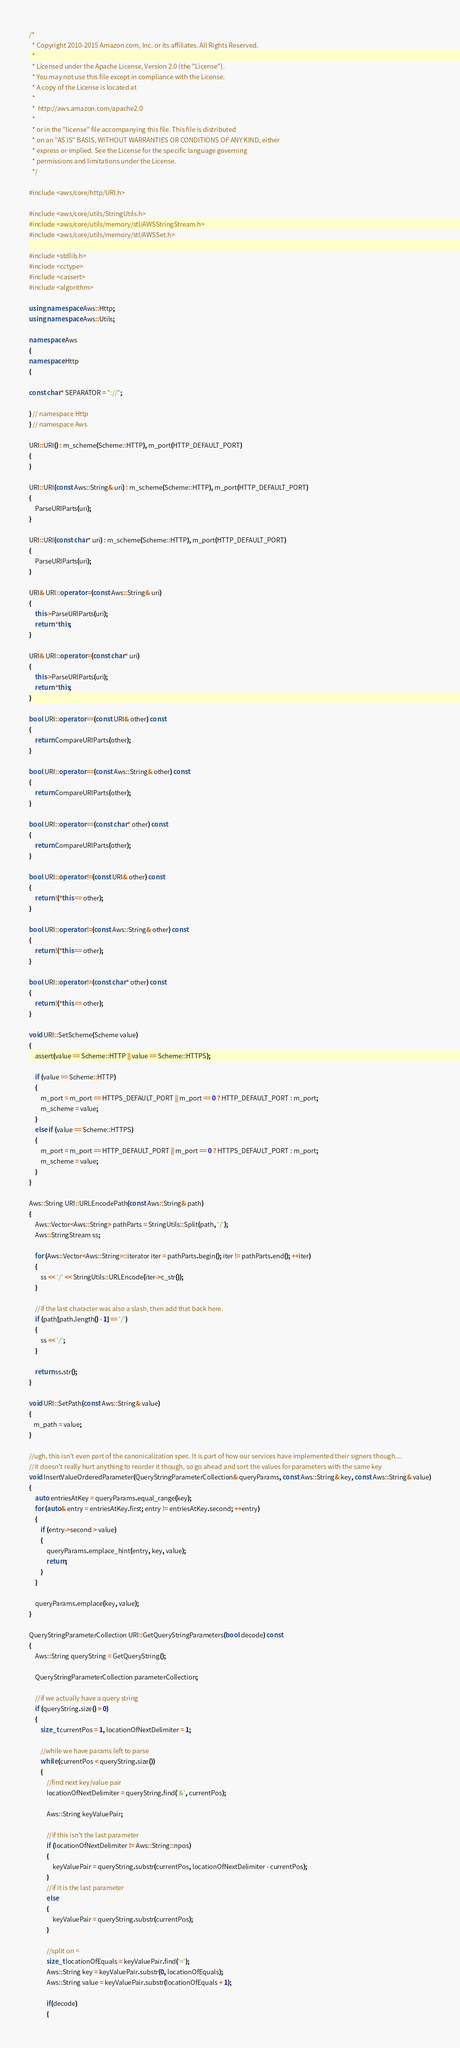Convert code to text. <code><loc_0><loc_0><loc_500><loc_500><_C++_>/*
  * Copyright 2010-2015 Amazon.com, Inc. or its affiliates. All Rights Reserved.
  * 
  * Licensed under the Apache License, Version 2.0 (the "License").
  * You may not use this file except in compliance with the License.
  * A copy of the License is located at
  * 
  *  http://aws.amazon.com/apache2.0
  * 
  * or in the "license" file accompanying this file. This file is distributed
  * on an "AS IS" BASIS, WITHOUT WARRANTIES OR CONDITIONS OF ANY KIND, either
  * express or implied. See the License for the specific language governing
  * permissions and limitations under the License.
  */

#include <aws/core/http/URI.h>

#include <aws/core/utils/StringUtils.h>
#include <aws/core/utils/memory/stl/AWSStringStream.h>
#include <aws/core/utils/memory/stl/AWSSet.h>

#include <stdlib.h>
#include <cctype>
#include <cassert>
#include <algorithm>

using namespace Aws::Http;
using namespace Aws::Utils;

namespace Aws
{
namespace Http
{

const char* SEPARATOR = "://";

} // namespace Http
} // namespace Aws

URI::URI() : m_scheme(Scheme::HTTP), m_port(HTTP_DEFAULT_PORT)
{
}

URI::URI(const Aws::String& uri) : m_scheme(Scheme::HTTP), m_port(HTTP_DEFAULT_PORT)
{
    ParseURIParts(uri);
}

URI::URI(const char* uri) : m_scheme(Scheme::HTTP), m_port(HTTP_DEFAULT_PORT)
{
    ParseURIParts(uri);
}

URI& URI::operator =(const Aws::String& uri)
{
    this->ParseURIParts(uri);
    return *this;
}

URI& URI::operator =(const char* uri)
{
    this->ParseURIParts(uri);
    return *this;
}

bool URI::operator ==(const URI& other) const
{
    return CompareURIParts(other);
}

bool URI::operator ==(const Aws::String& other) const
{
    return CompareURIParts(other);
}

bool URI::operator ==(const char* other) const
{
    return CompareURIParts(other);
}

bool URI::operator !=(const URI& other) const
{
    return !(*this == other);
}

bool URI::operator !=(const Aws::String& other) const
{
    return !(*this == other);
}

bool URI::operator !=(const char* other) const
{
    return !(*this == other);
}

void URI::SetScheme(Scheme value)
{
    assert(value == Scheme::HTTP || value == Scheme::HTTPS);

    if (value == Scheme::HTTP)
    {
        m_port = m_port == HTTPS_DEFAULT_PORT || m_port == 0 ? HTTP_DEFAULT_PORT : m_port;
        m_scheme = value;
    }
    else if (value == Scheme::HTTPS)
    {
        m_port = m_port == HTTP_DEFAULT_PORT || m_port == 0 ? HTTPS_DEFAULT_PORT : m_port;
        m_scheme = value;
    }
}

Aws::String URI::URLEncodePath(const Aws::String& path)
{
    Aws::Vector<Aws::String> pathParts = StringUtils::Split(path, '/');
    Aws::StringStream ss;

    for (Aws::Vector<Aws::String>::iterator iter = pathParts.begin(); iter != pathParts.end(); ++iter)
    {
        ss << '/' << StringUtils::URLEncode(iter->c_str());
    }

    //if the last character was also a slash, then add that back here.
    if (path[path.length() - 1] == '/')
    {
        ss << '/';
    }

    return ss.str();
}

void URI::SetPath(const Aws::String& value)
{    
   m_path = value;
}

//ugh, this isn't even part of the canonicalization spec. It is part of how our services have implemented their signers though....
//it doesn't really hurt anything to reorder it though, so go ahead and sort the values for parameters with the same key 
void InsertValueOrderedParameter(QueryStringParameterCollection& queryParams, const Aws::String& key, const Aws::String& value)
{
    auto entriesAtKey = queryParams.equal_range(key);
    for (auto& entry = entriesAtKey.first; entry != entriesAtKey.second; ++entry)
    {
        if (entry->second > value)
        {
            queryParams.emplace_hint(entry, key, value);            
            return;
        }
    }

    queryParams.emplace(key, value);
}

QueryStringParameterCollection URI::GetQueryStringParameters(bool decode) const
{
    Aws::String queryString = GetQueryString();

    QueryStringParameterCollection parameterCollection;

    //if we actually have a query string
    if (queryString.size() > 0)
    {
        size_t currentPos = 1, locationOfNextDelimiter = 1;

        //while we have params left to parse
        while (currentPos < queryString.size())
        {
            //find next key/value pair
            locationOfNextDelimiter = queryString.find('&', currentPos);

            Aws::String keyValuePair;

            //if this isn't the last parameter
            if (locationOfNextDelimiter != Aws::String::npos)
            {
                keyValuePair = queryString.substr(currentPos, locationOfNextDelimiter - currentPos);
            }
            //if it is the last parameter
            else
            {
                keyValuePair = queryString.substr(currentPos);
            }

            //split on =
            size_t locationOfEquals = keyValuePair.find('=');
            Aws::String key = keyValuePair.substr(0, locationOfEquals);
            Aws::String value = keyValuePair.substr(locationOfEquals + 1);

            if(decode)
            {</code> 